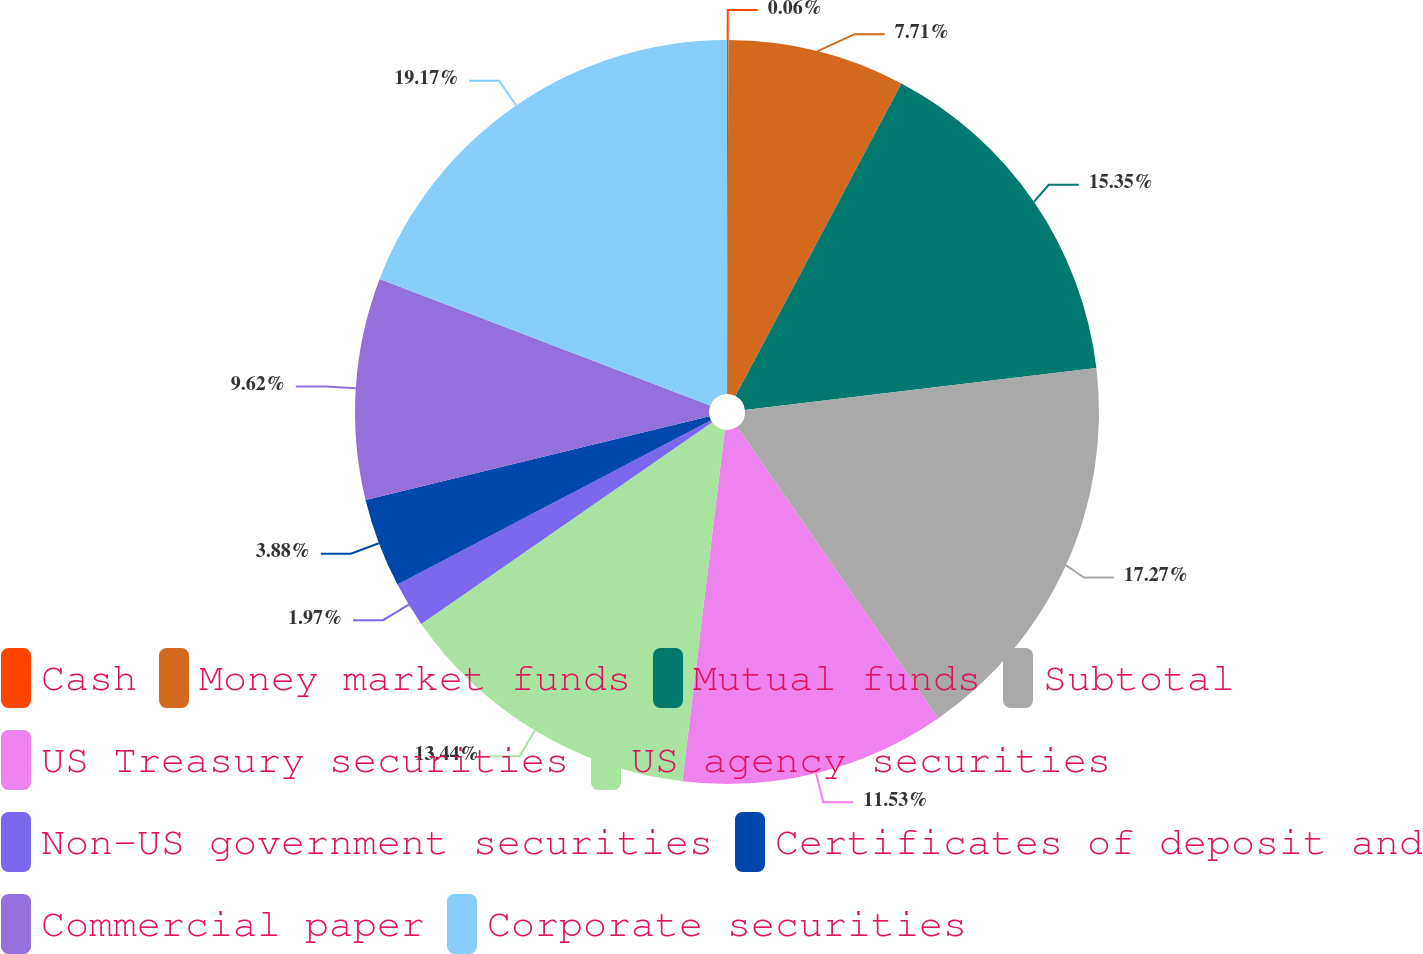<chart> <loc_0><loc_0><loc_500><loc_500><pie_chart><fcel>Cash<fcel>Money market funds<fcel>Mutual funds<fcel>Subtotal<fcel>US Treasury securities<fcel>US agency securities<fcel>Non-US government securities<fcel>Certificates of deposit and<fcel>Commercial paper<fcel>Corporate securities<nl><fcel>0.06%<fcel>7.71%<fcel>15.35%<fcel>17.27%<fcel>11.53%<fcel>13.44%<fcel>1.97%<fcel>3.88%<fcel>9.62%<fcel>19.18%<nl></chart> 